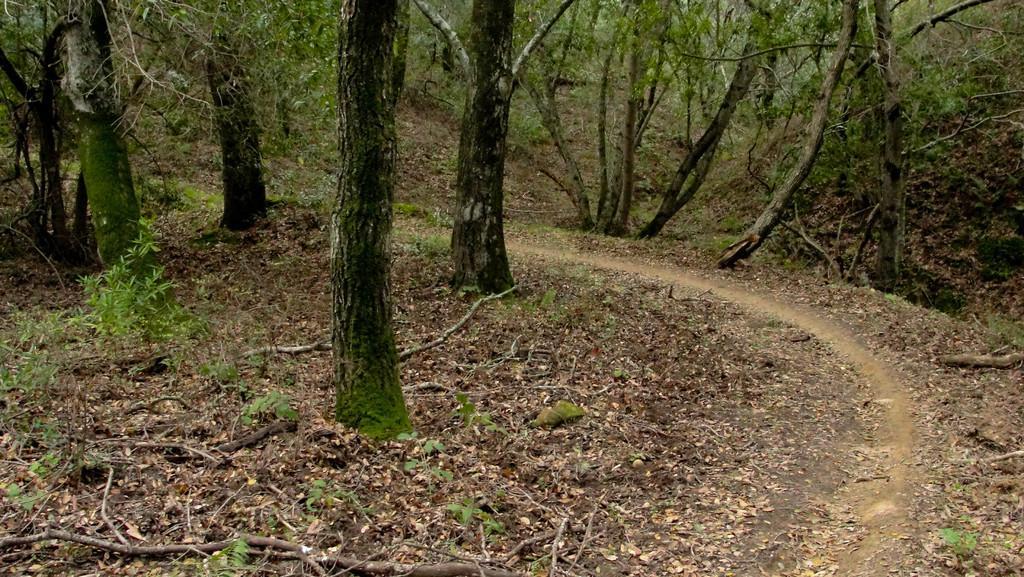Describe this image in one or two sentences. This image is taken outdoors. At the bottom of the image there is a ground with grass, a few sticks and many dry leaves on it. In the background there are many trees and plants. 